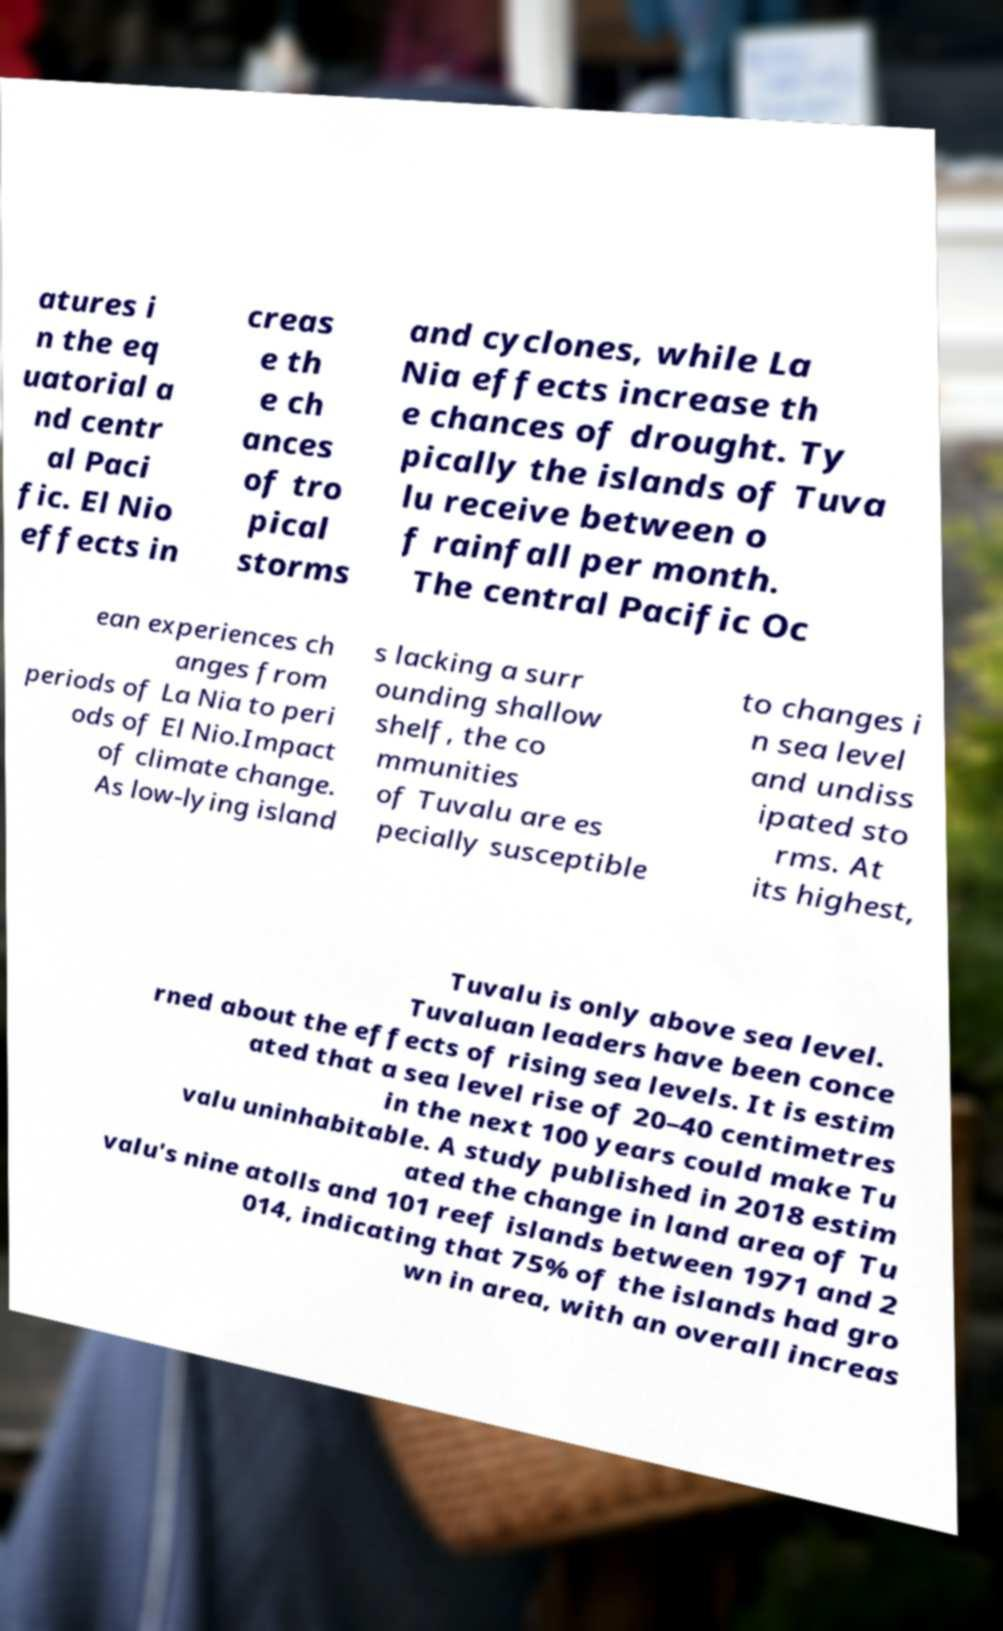Please read and relay the text visible in this image. What does it say? atures i n the eq uatorial a nd centr al Paci fic. El Nio effects in creas e th e ch ances of tro pical storms and cyclones, while La Nia effects increase th e chances of drought. Ty pically the islands of Tuva lu receive between o f rainfall per month. The central Pacific Oc ean experiences ch anges from periods of La Nia to peri ods of El Nio.Impact of climate change. As low-lying island s lacking a surr ounding shallow shelf, the co mmunities of Tuvalu are es pecially susceptible to changes i n sea level and undiss ipated sto rms. At its highest, Tuvalu is only above sea level. Tuvaluan leaders have been conce rned about the effects of rising sea levels. It is estim ated that a sea level rise of 20–40 centimetres in the next 100 years could make Tu valu uninhabitable. A study published in 2018 estim ated the change in land area of Tu valu's nine atolls and 101 reef islands between 1971 and 2 014, indicating that 75% of the islands had gro wn in area, with an overall increas 